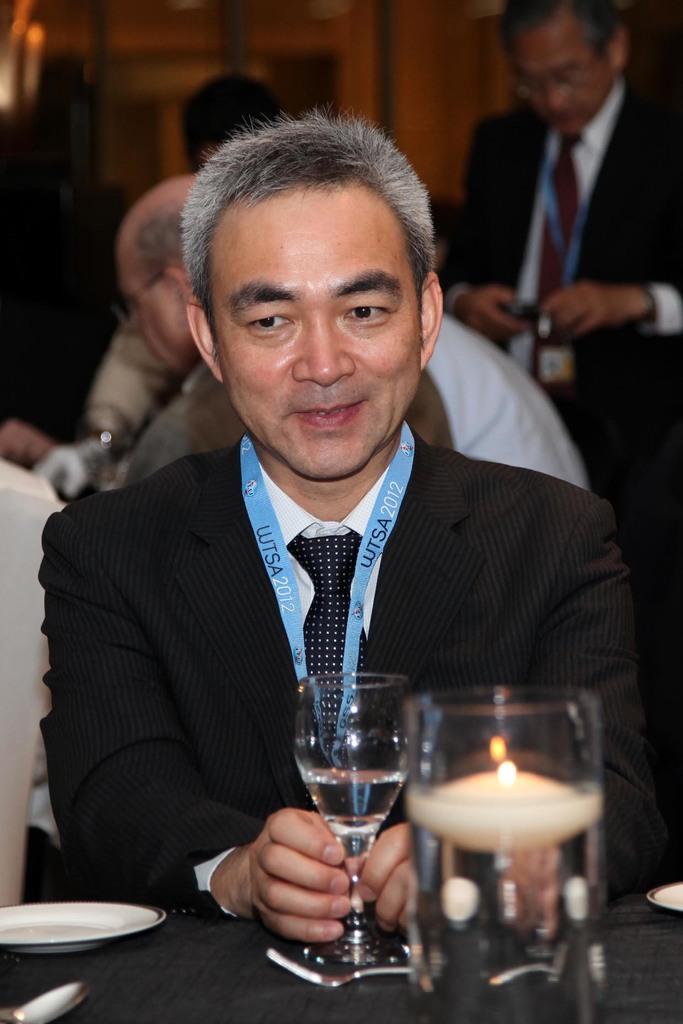Describe this image in one or two sentences. In this image I can see the person is holding the glass. I can see the plate, spoon, candle and few objects on the table. In the background I can see few people around. 